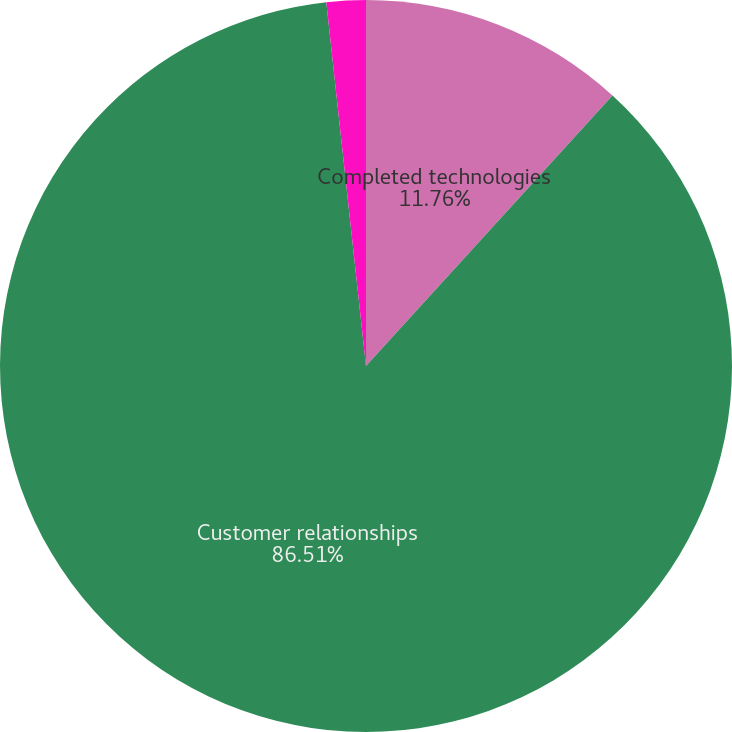Convert chart to OTSL. <chart><loc_0><loc_0><loc_500><loc_500><pie_chart><fcel>Completed technologies<fcel>Customer relationships<fcel>Trademarks<nl><fcel>11.76%<fcel>86.51%<fcel>1.73%<nl></chart> 